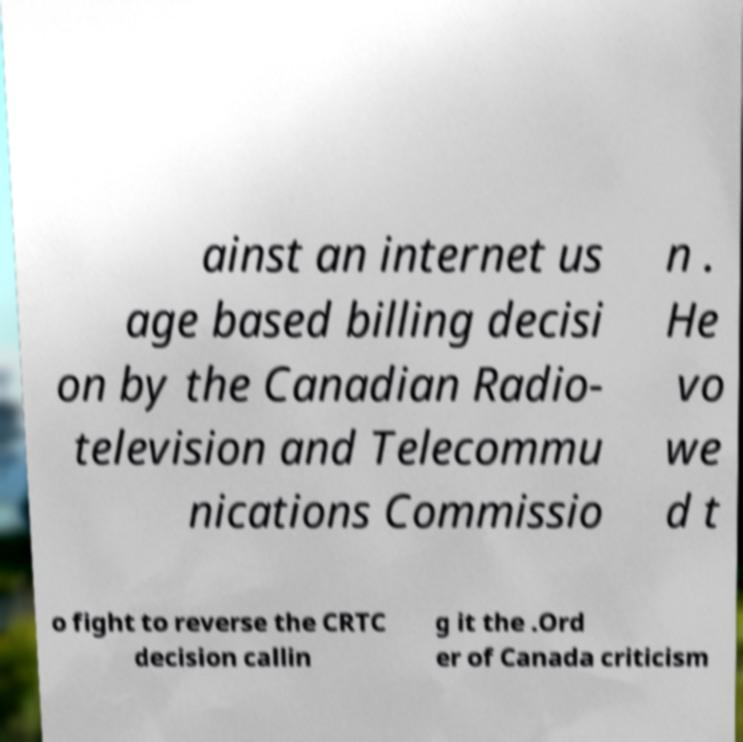Can you read and provide the text displayed in the image?This photo seems to have some interesting text. Can you extract and type it out for me? ainst an internet us age based billing decisi on by the Canadian Radio- television and Telecommu nications Commissio n . He vo we d t o fight to reverse the CRTC decision callin g it the .Ord er of Canada criticism 